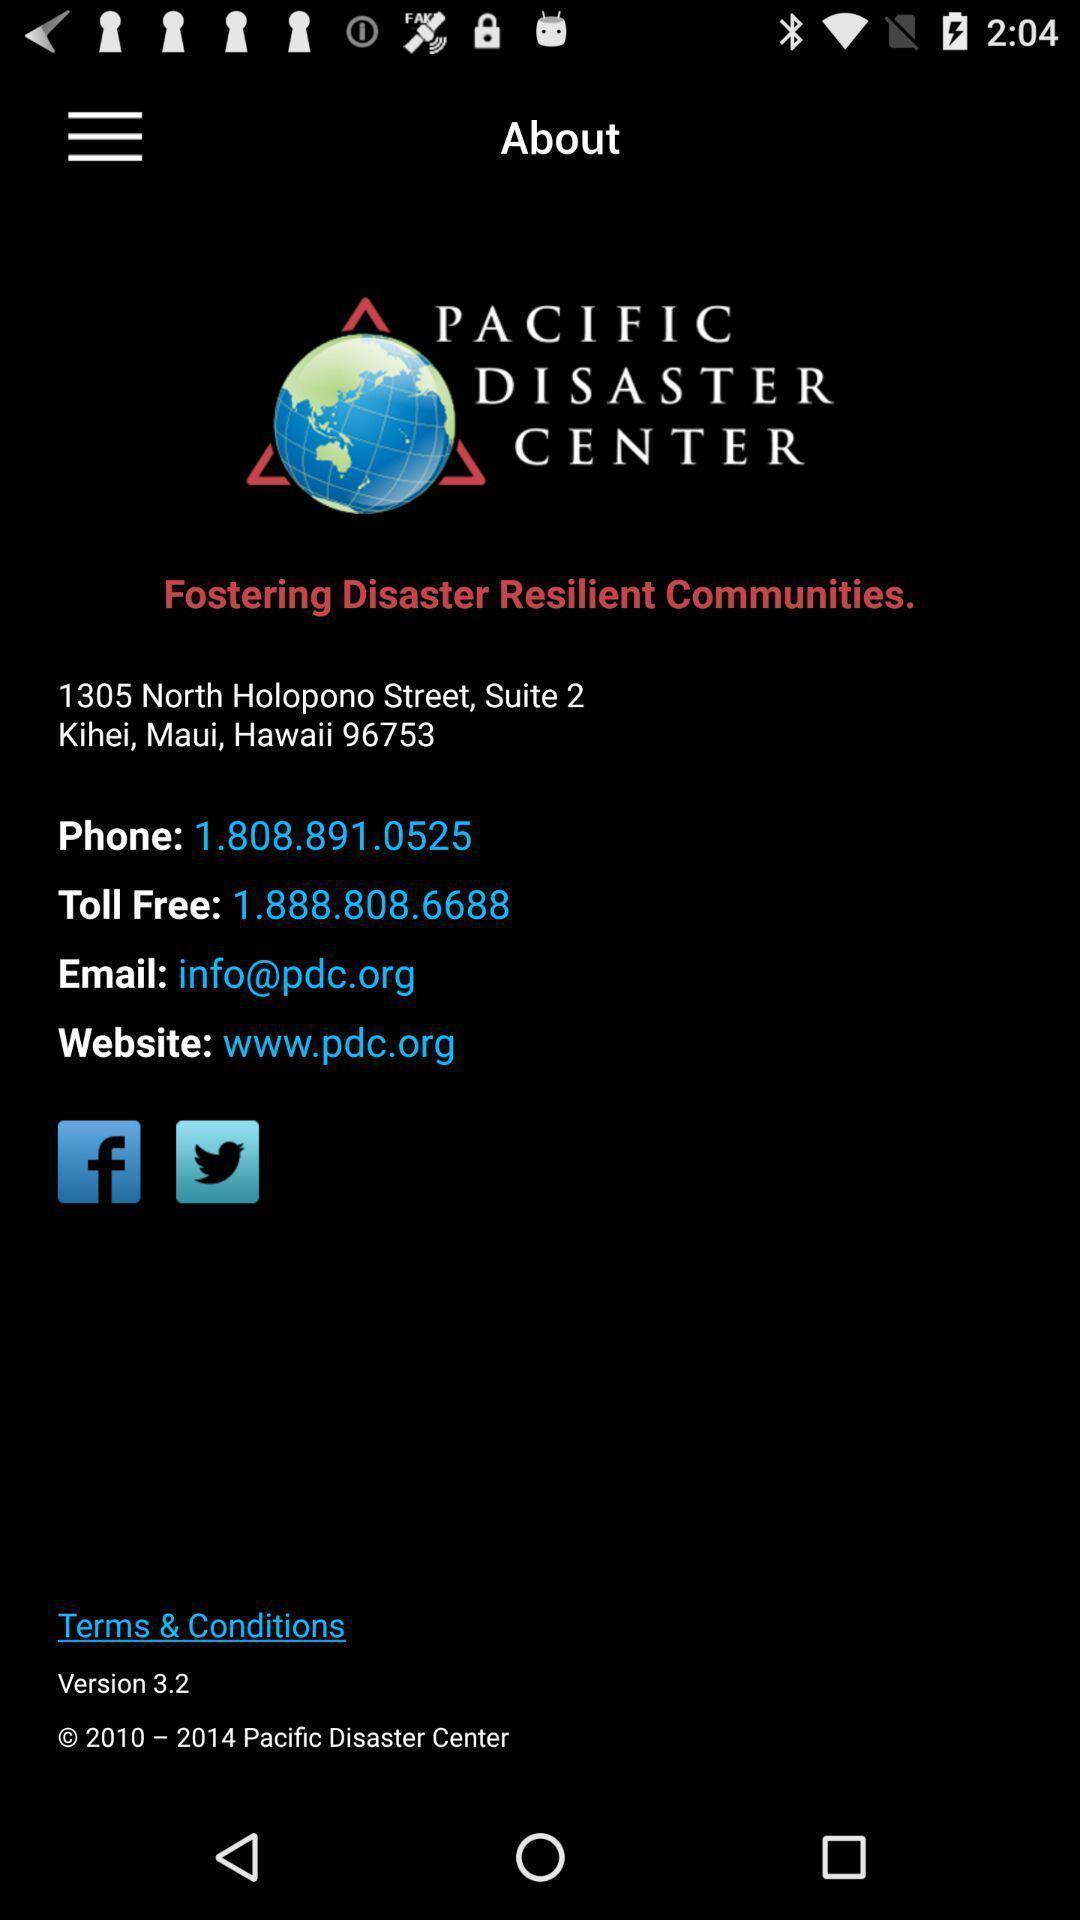Summarize the main components in this picture. Welcome page. 